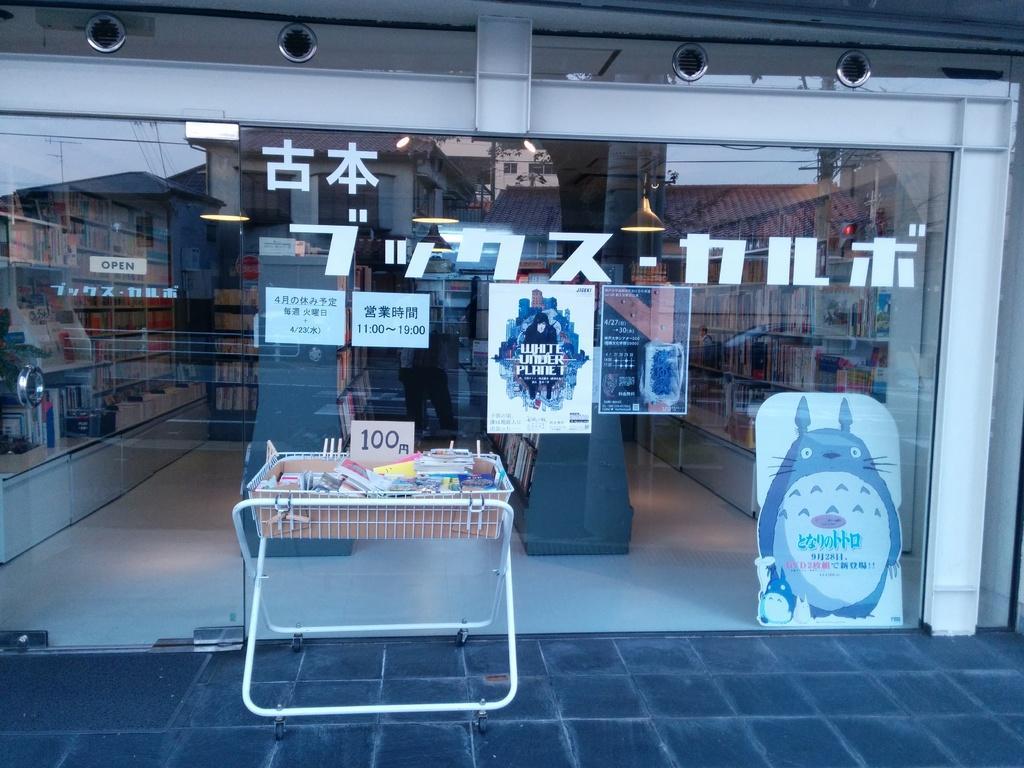How would you summarize this image in a sentence or two? In the foreground of the image we can see a table with some objects and board with text place on the ground. In the background, we can see a glass door with some posters , group of books placed in racks and some lights. 